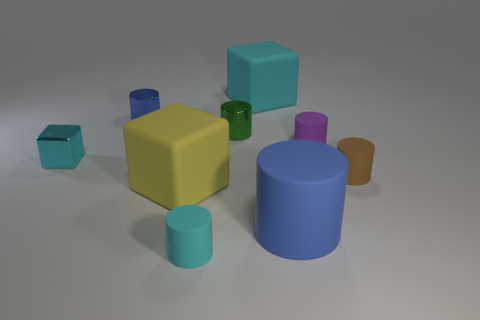Subtract 1 cylinders. How many cylinders are left? 5 Subtract all brown cylinders. How many cylinders are left? 5 Subtract all big rubber cylinders. How many cylinders are left? 5 Subtract all yellow cylinders. Subtract all brown cubes. How many cylinders are left? 6 Subtract all cubes. How many objects are left? 6 Subtract all small cyan matte balls. Subtract all cyan blocks. How many objects are left? 7 Add 4 cyan matte cylinders. How many cyan matte cylinders are left? 5 Add 7 metal cylinders. How many metal cylinders exist? 9 Subtract 0 yellow balls. How many objects are left? 9 